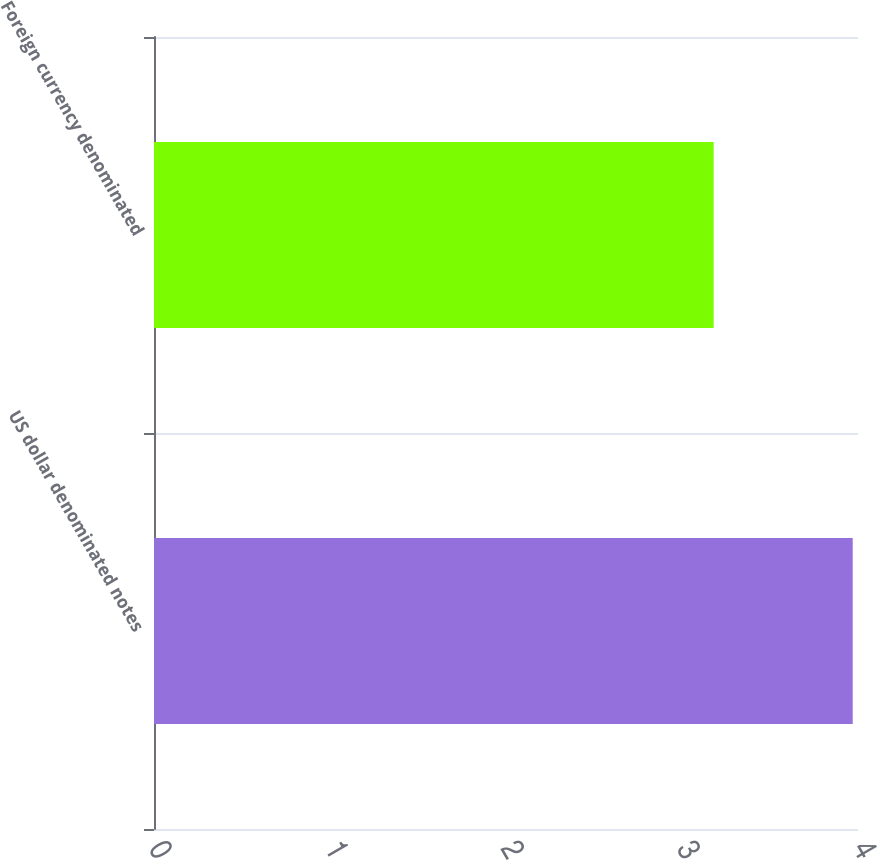Convert chart. <chart><loc_0><loc_0><loc_500><loc_500><bar_chart><fcel>US dollar denominated notes<fcel>Foreign currency denominated<nl><fcel>3.97<fcel>3.18<nl></chart> 